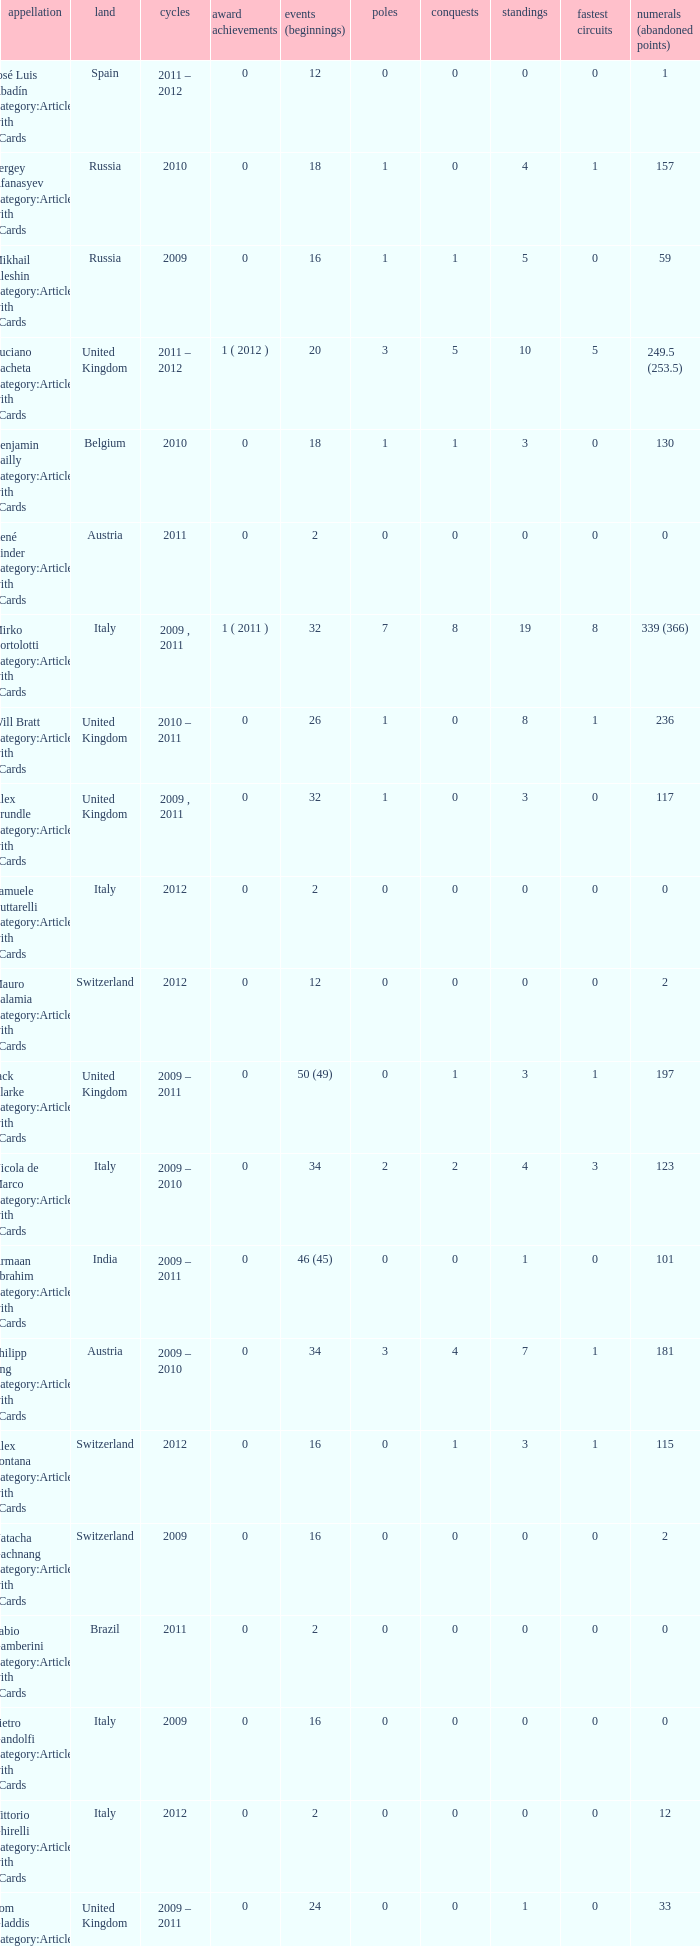When did they win 7 races? 2009.0. 